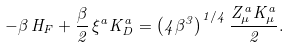Convert formula to latex. <formula><loc_0><loc_0><loc_500><loc_500>- \beta \, H _ { F } + \frac { \beta } { 2 } \, \xi ^ { a } K _ { D } ^ { a } = \left ( 4 \beta ^ { 3 } \right ) ^ { 1 / 4 } \frac { Z _ { \mu } ^ { a } K _ { \mu } ^ { a } } { 2 } .</formula> 